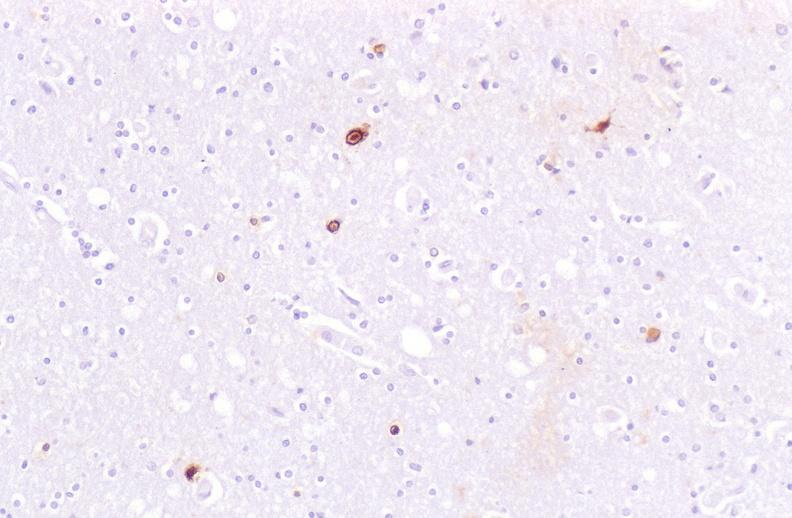where is this?
Answer the question using a single word or phrase. Nervous 